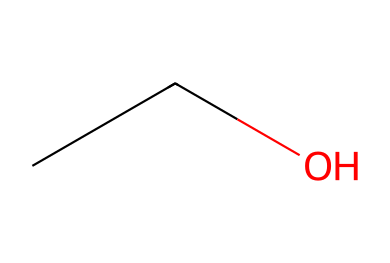What is the name of this chemical? The SMILES representation "CCO" corresponds to ethanol, which is a simple alcohol.
Answer: ethanol How many carbon atoms are present in this structure? The "CC" in the SMILES indicates there are two carbon atoms connected together in the structure of ethanol.
Answer: 2 What type of compound is this? Ethanol is classified as an alcohol due to the presence of a hydroxyl group (-OH) in its structure, which is implied by the "O" in the SMILES.
Answer: alcohol What is the molecular formula of this compound? From the SMILES "CCO", the structure contains 2 carbon (C), 6 hydrogen (H), and 1 oxygen (O) atom, which leads to the molecular formula C2H6O.
Answer: C2H6O What is the total number of hydrogen atoms in this structure? The structure of ethanol has a total of 6 hydrogen atoms attached to the two carbon atoms and the hydroxyl group, as indicated by the saturation of carbon and the presence of the hydroxyl group.
Answer: 6 What functional group is present in this compound? The presence of the hydroxyl group (-OH) in the structure "CCO" identifies it as an alcohol, which is the functional group that characterizes ethanol.
Answer: hydroxyl group 